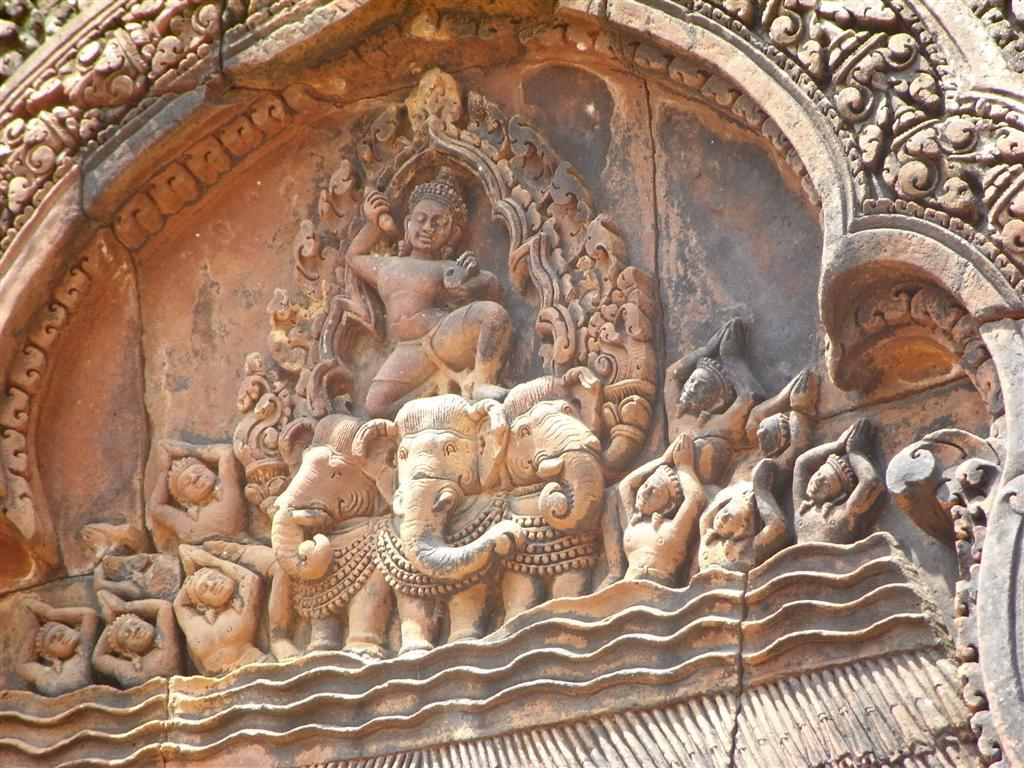What is the main subject of the image? The main subject of the image is a sculpture. What does the sculpture depict? The sculpture depicts animals and persons. Where is the sculpture located? The sculpture is on a stone wall. How does the sculpture move around in the image? The sculpture does not move around in the image; it is a stationary object made of a solid material. 